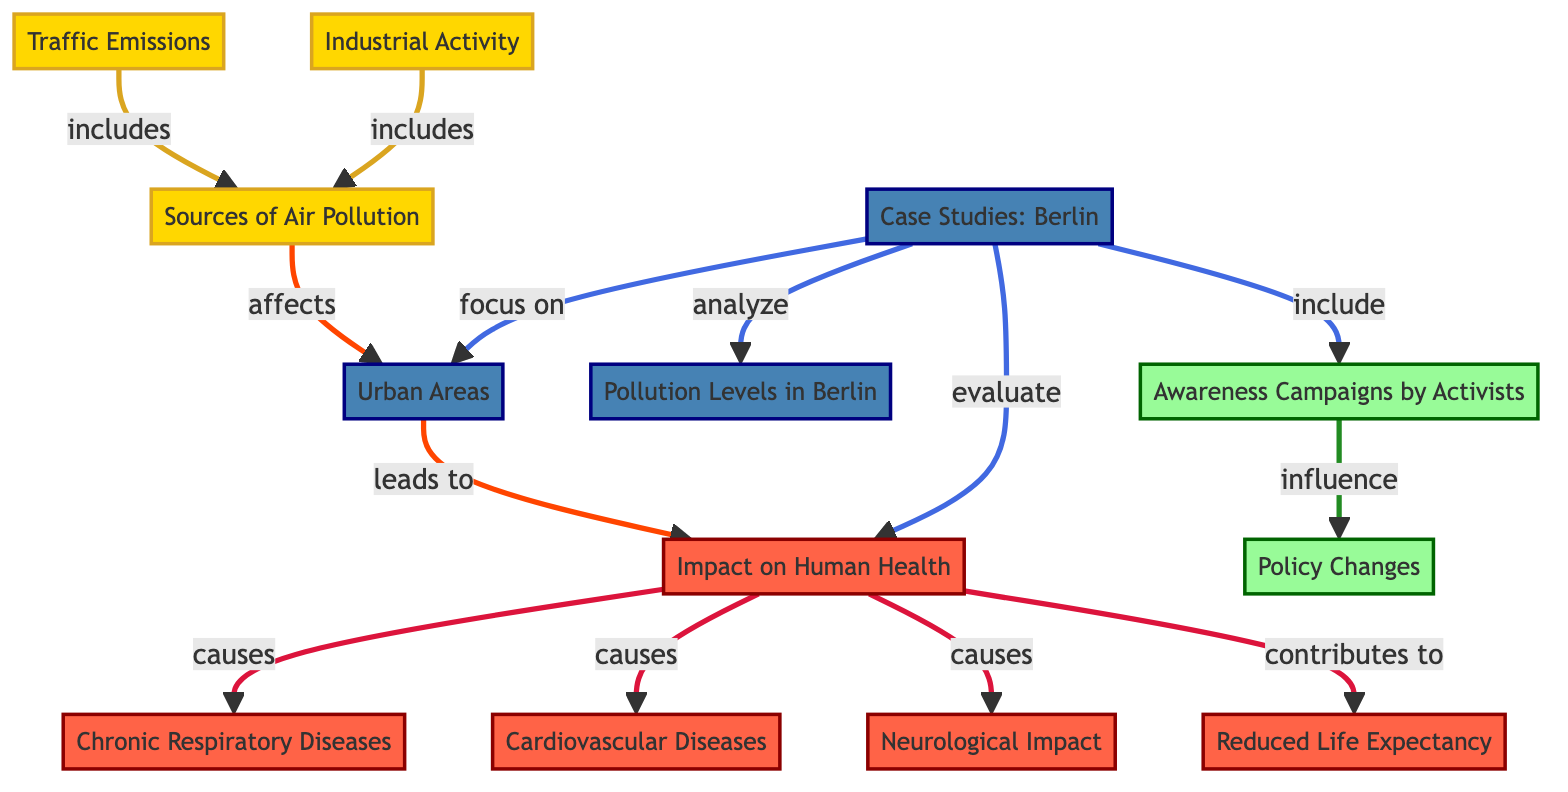What are the main sources of air pollution mentioned? The diagram indicates that the sources of air pollution are Traffic Emissions and Industrial Activity. Both are classified as source nodes in the diagram, leading to the impact on urban areas.
Answer: Traffic Emissions, Industrial Activity How many nodes represent the impact on human health? In the diagram, there are four impact nodes linked to human health: Chronic Respiratory Diseases, Cardiovascular Diseases, Neurological Impact, and Reduced Life Expectancy, totaling four nodes.
Answer: Four What is the relationship between urban areas and human health impacts? The diagram illustrates that urban areas lead to human health impacts, connecting these two sets of nodes directly. As urban areas are adversely affected by pollution, they subsequently result in health issues.
Answer: Leads to Which case studies focus on the urban areas? The case studies focusing on urban areas are specifically indicated as Berlin, represented by the node labeled Case Studies: Berlin, which evaluates urban health impacts and pollution levels.
Answer: Berlin How do awareness campaigns influence policy changes? The diagram shows a connection where awareness campaigns by activists influence policy changes, indicating that as awareness increases, it leads to changes in policies regarding air pollution.
Answer: Influence What health conditions are directly caused by the impact on human health? Four health conditions are directly connected to the impact on human health: Chronic Respiratory Diseases, Cardiovascular Diseases, Neurological Impact, and Reduced Life Expectancy, illustrating the severity of health consequences.
Answer: Chronic Respiratory Diseases, Cardiovascular Diseases, Neurological Impact, Reduced Life Expectancy What is the significance of the pollution levels in Berlin? The pollution levels in Berlin are analyzed in the case studies, which focus on the urban areas and evaluate their health impacts, making it a crucial part of understanding air pollution effects in the city.
Answer: Evaluate How do traffic emissions relate to sources of air pollution? The diagram specifies that traffic emissions are included as a source of air pollution, indicating that they contribute to the overall pollution in urban areas, which affects human health.
Answer: Includes 